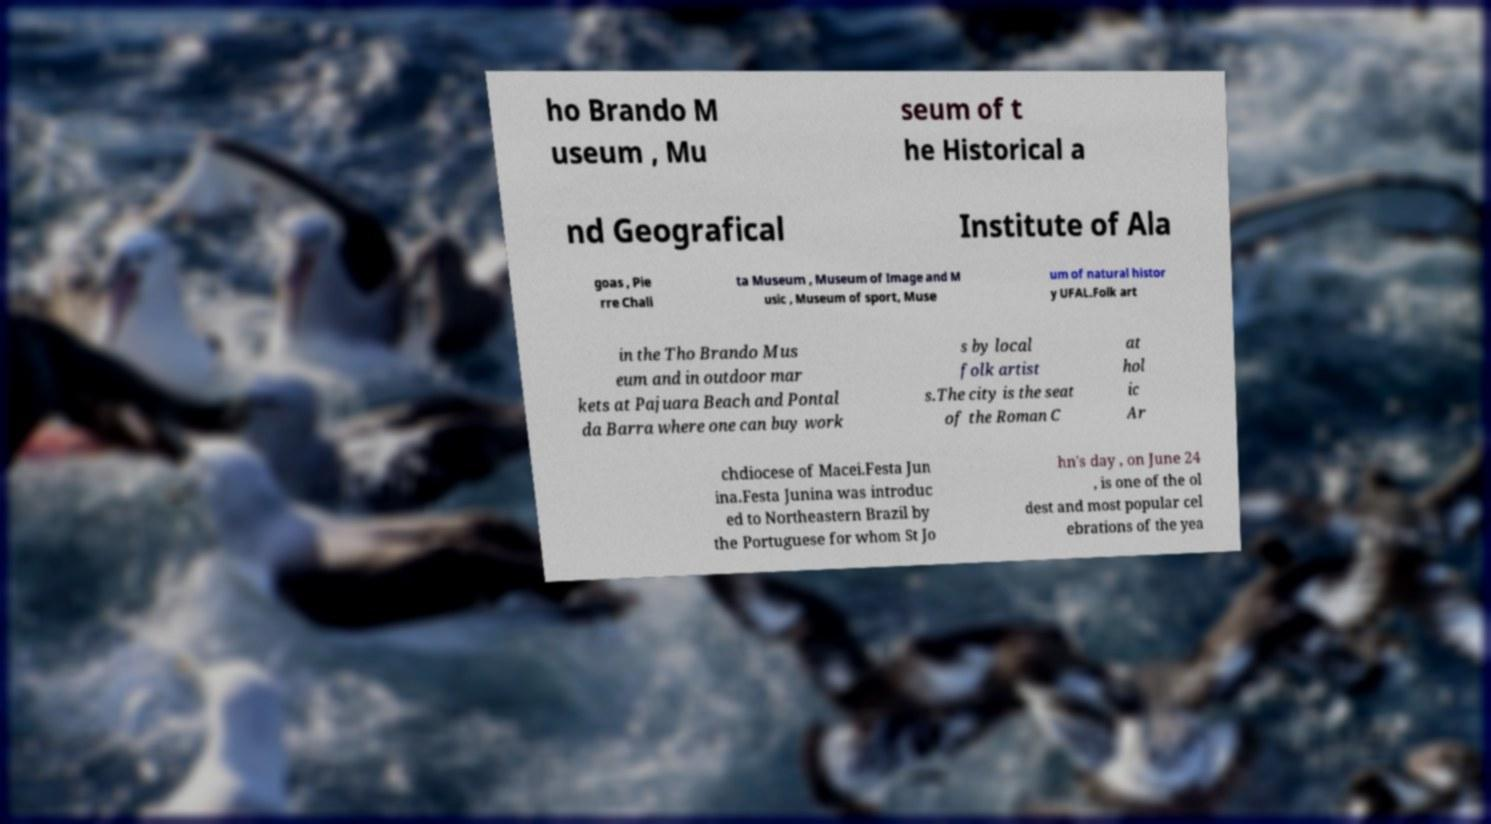Can you read and provide the text displayed in the image?This photo seems to have some interesting text. Can you extract and type it out for me? ho Brando M useum , Mu seum of t he Historical a nd Geografical Institute of Ala goas , Pie rre Chali ta Museum , Museum of Image and M usic , Museum of sport, Muse um of natural histor y UFAL.Folk art in the Tho Brando Mus eum and in outdoor mar kets at Pajuara Beach and Pontal da Barra where one can buy work s by local folk artist s.The city is the seat of the Roman C at hol ic Ar chdiocese of Macei.Festa Jun ina.Festa Junina was introduc ed to Northeastern Brazil by the Portuguese for whom St Jo hn's day , on June 24 , is one of the ol dest and most popular cel ebrations of the yea 